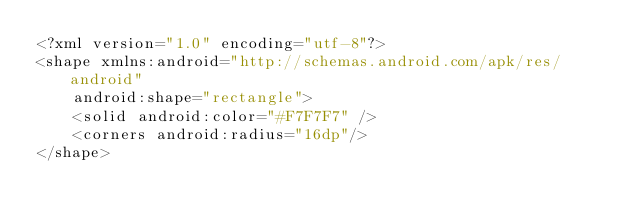Convert code to text. <code><loc_0><loc_0><loc_500><loc_500><_XML_><?xml version="1.0" encoding="utf-8"?>
<shape xmlns:android="http://schemas.android.com/apk/res/android"
    android:shape="rectangle">
    <solid android:color="#F7F7F7" />
    <corners android:radius="16dp"/>
</shape></code> 